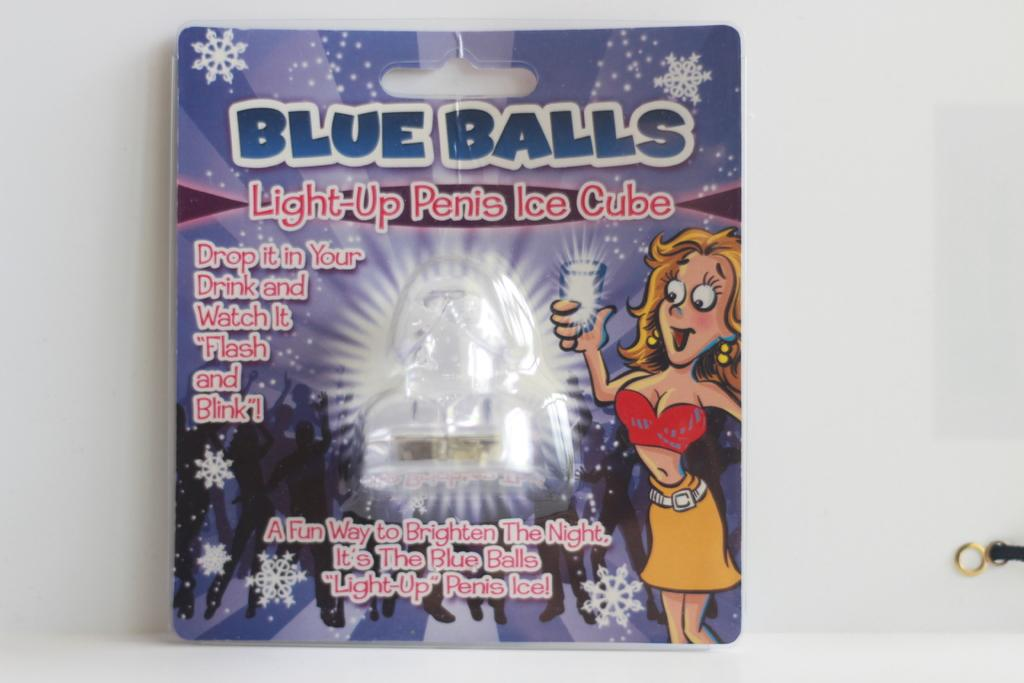What is on the front of the packet in the image? There is a front page or label card on a packet in the image. What can be found on the label card? The label card has some text on it. Is there any illustration or image on the label card? Yes, there is a cartoon of a woman in the image. How many kitties are playing with the fowl in the image? There are no kitties or fowl present in the image; it only features a front page or label card with a cartoon of a woman. What type of skin is visible on the woman in the image? There is no visible skin on the woman in the image, as it is a cartoon drawing. 